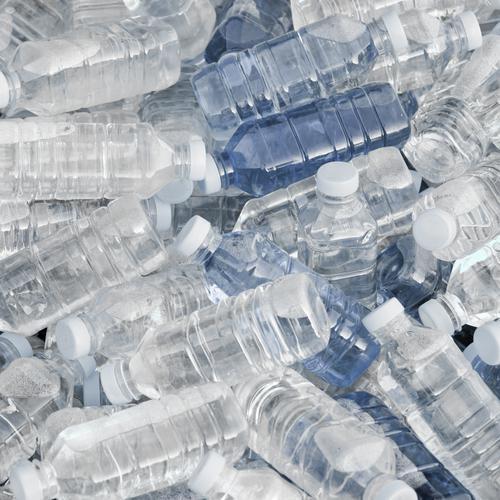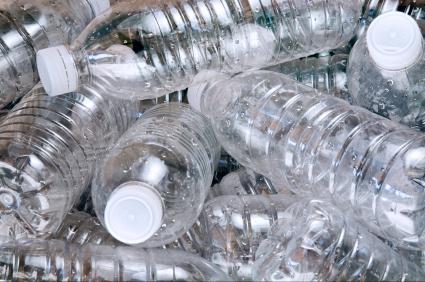The first image is the image on the left, the second image is the image on the right. Analyze the images presented: Is the assertion "At least one image shows all bottles with white caps." valid? Answer yes or no. Yes. The first image is the image on the left, the second image is the image on the right. Analyze the images presented: Is the assertion "In at least one image, bottles are capped with only white lids." valid? Answer yes or no. Yes. 